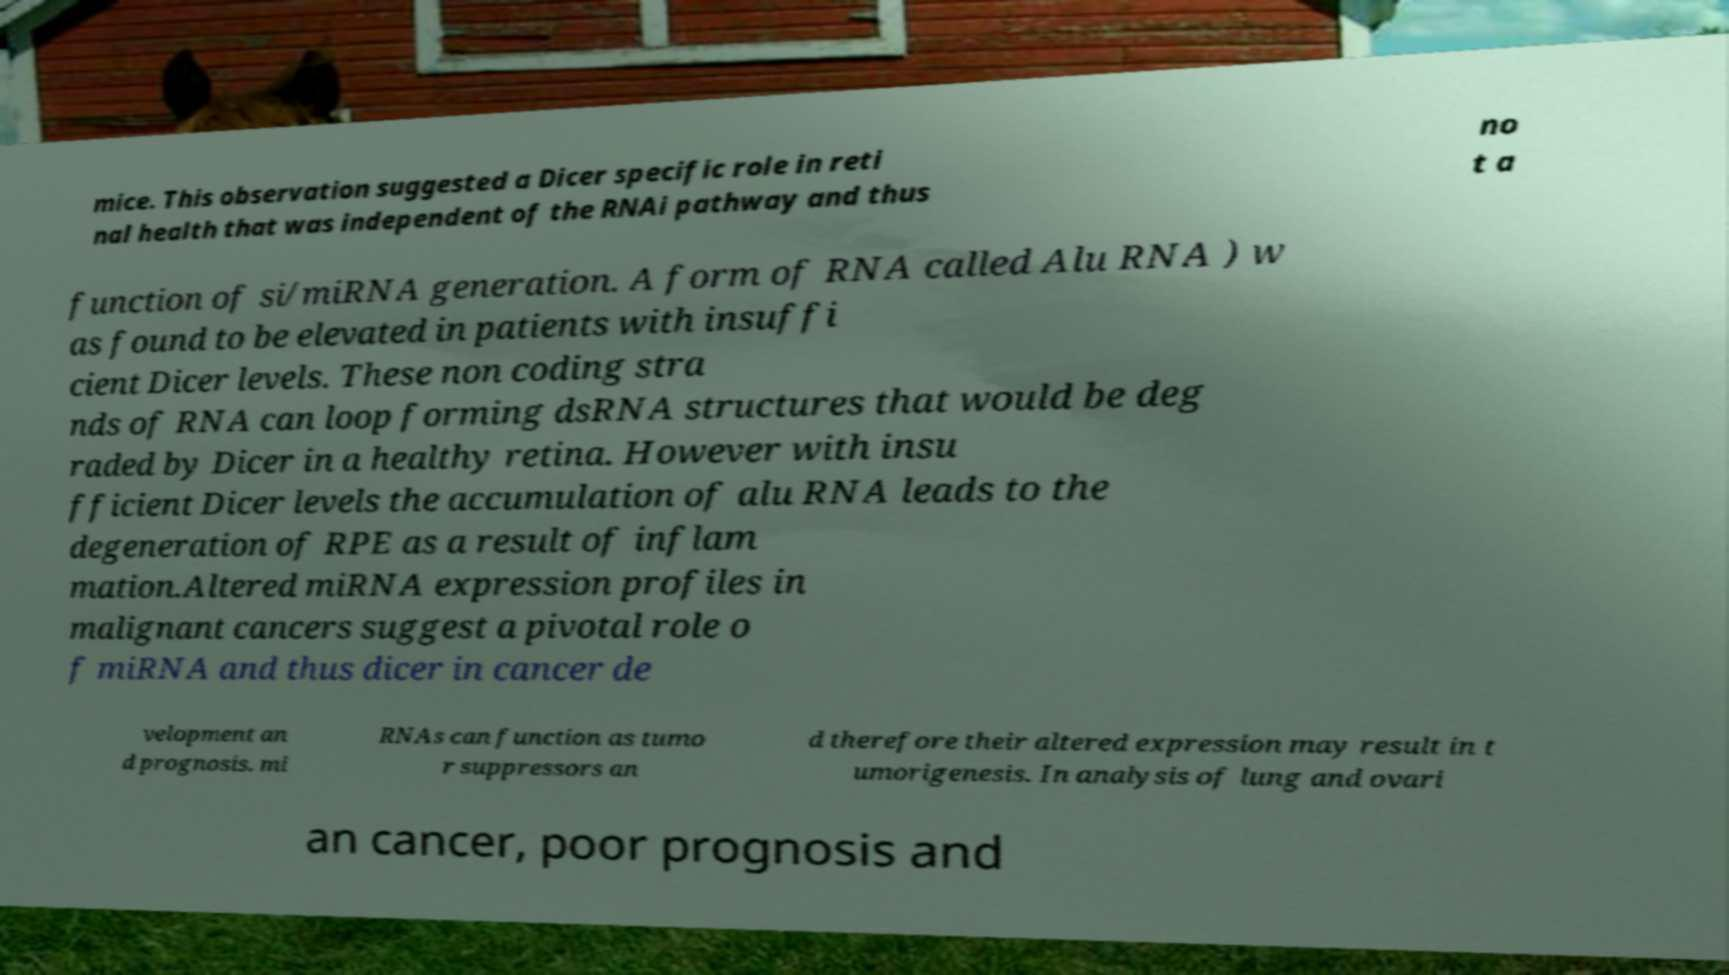There's text embedded in this image that I need extracted. Can you transcribe it verbatim? mice. This observation suggested a Dicer specific role in reti nal health that was independent of the RNAi pathway and thus no t a function of si/miRNA generation. A form of RNA called Alu RNA ) w as found to be elevated in patients with insuffi cient Dicer levels. These non coding stra nds of RNA can loop forming dsRNA structures that would be deg raded by Dicer in a healthy retina. However with insu fficient Dicer levels the accumulation of alu RNA leads to the degeneration of RPE as a result of inflam mation.Altered miRNA expression profiles in malignant cancers suggest a pivotal role o f miRNA and thus dicer in cancer de velopment an d prognosis. mi RNAs can function as tumo r suppressors an d therefore their altered expression may result in t umorigenesis. In analysis of lung and ovari an cancer, poor prognosis and 